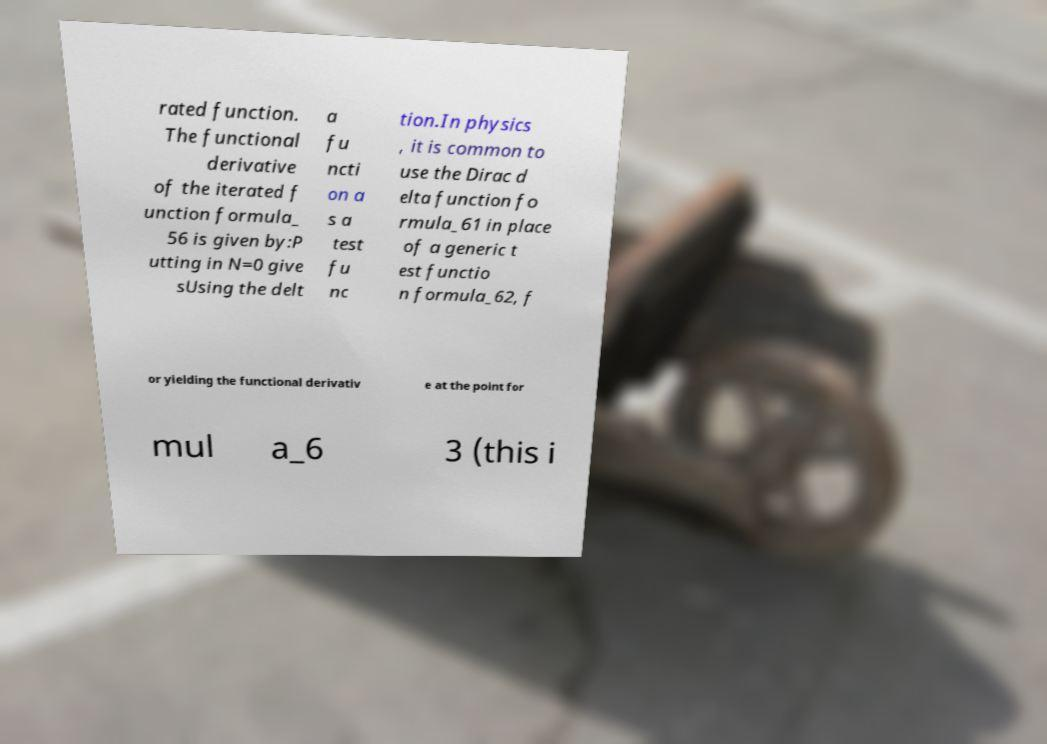Please identify and transcribe the text found in this image. rated function. The functional derivative of the iterated f unction formula_ 56 is given by:P utting in N=0 give sUsing the delt a fu ncti on a s a test fu nc tion.In physics , it is common to use the Dirac d elta function fo rmula_61 in place of a generic t est functio n formula_62, f or yielding the functional derivativ e at the point for mul a_6 3 (this i 